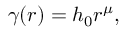Convert formula to latex. <formula><loc_0><loc_0><loc_500><loc_500>\gamma ( r ) = h _ { 0 } r ^ { \mu } ,</formula> 